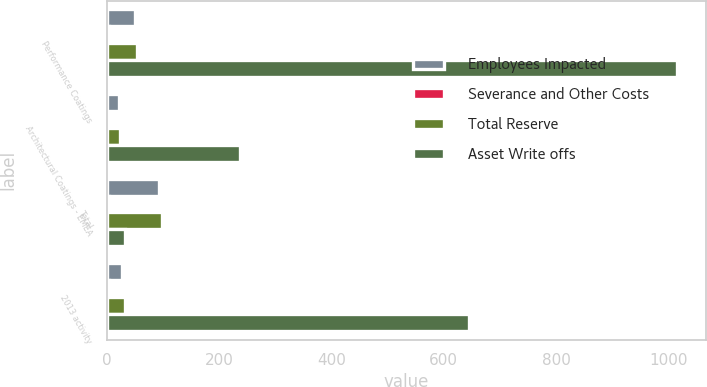Convert chart. <chart><loc_0><loc_0><loc_500><loc_500><stacked_bar_chart><ecel><fcel>Performance Coatings<fcel>Architectural Coatings - EMEA<fcel>Total<fcel>2013 activity<nl><fcel>Employees Impacted<fcel>51<fcel>23<fcel>93<fcel>27<nl><fcel>Severance and Other Costs<fcel>4<fcel>1<fcel>5<fcel>5<nl><fcel>Total Reserve<fcel>55<fcel>24<fcel>98<fcel>32<nl><fcel>Asset Write offs<fcel>1016<fcel>237<fcel>32<fcel>645<nl></chart> 